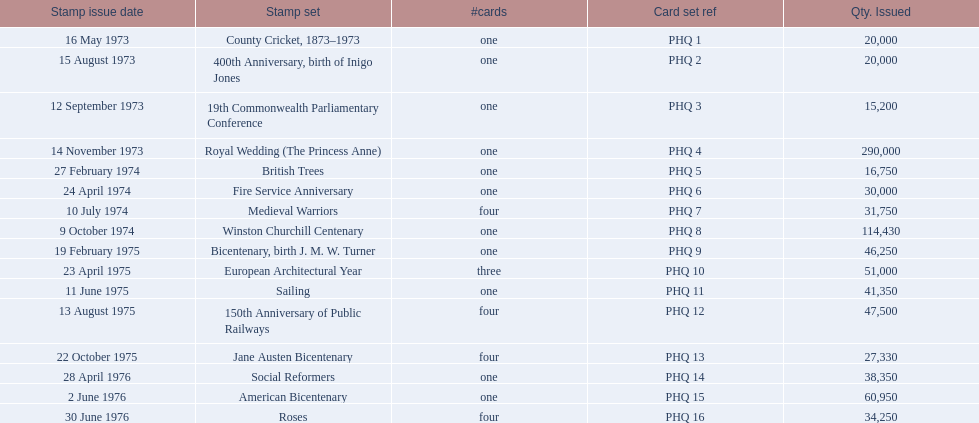What are the stamp sets included in the phq? County Cricket, 1873–1973, 400th Anniversary, birth of Inigo Jones, 19th Commonwealth Parliamentary Conference, Royal Wedding (The Princess Anne), British Trees, Fire Service Anniversary, Medieval Warriors, Winston Churchill Centenary, Bicentenary, birth J. M. W. Turner, European Architectural Year, Sailing, 150th Anniversary of Public Railways, Jane Austen Bicentenary, Social Reformers, American Bicentenary, Roses. Which stamp sets have a circulation of over 200,000? Royal Wedding (The Princess Anne). 